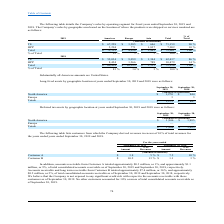According to Csp's financial document, How does the company sort its sales by? According to the financial document, Geographic area. The relevant text states: "2018. The Company’s sales by geographic area based on the location of where the products were shipped or services rendered are as follows:..." Also, How does the company determine its sales by geographic area? Based on the location of where the products were shipped or services rendered. The document states: "2018. The Company’s sales by geographic area based on the location of where the products were shipped or services rendered are as follows:..." Also, What percentage of the company's 2019 sales are from Asia? According to the financial document, 3%. The relevant text states: "operating segment for fiscal years ended September 30, 2019 and..." Also, can you calculate: What is the percentage change in Asia sales between 2018 and 2019? To answer this question, I need to perform calculations using the financial data. The calculation is: (2,483 - 2,133)/2,133 , which equals 16.41 (percentage). This is based on the information: "Total $ 60,458 $ 10,325 $ 2,133 $ 72,916 100 % Total $ 72,522 $ 4,056 $ 2,483 $ 79,061 100 %..." The key data points involved are: 2,133, 2,483. Also, can you calculate: What is the difference in total sales between 2018 and 2019? Based on the calculation: 79,061 - 72,916 , the result is 6145 (in thousands). This is based on the information: "Total $ 60,458 $ 10,325 $ 2,133 $ 72,916 100 % Total $ 72,522 $ 4,056 $ 2,483 $ 79,061 100 %..." The key data points involved are: 72,916, 79,061. Also, can you calculate: What is the difference in total sales between TS Asia and TS Europe in 2019? Based on the calculation: 3,285-646 , the result is 2639 (in thousands). This is based on the information: "TS $ 67,228 $ 3,285 $ 646 $ 71,159 90 % TS $ 67,228 $ 3,285 $ 646 $ 71,159 90 %..." The key data points involved are: 3,285, 646. 